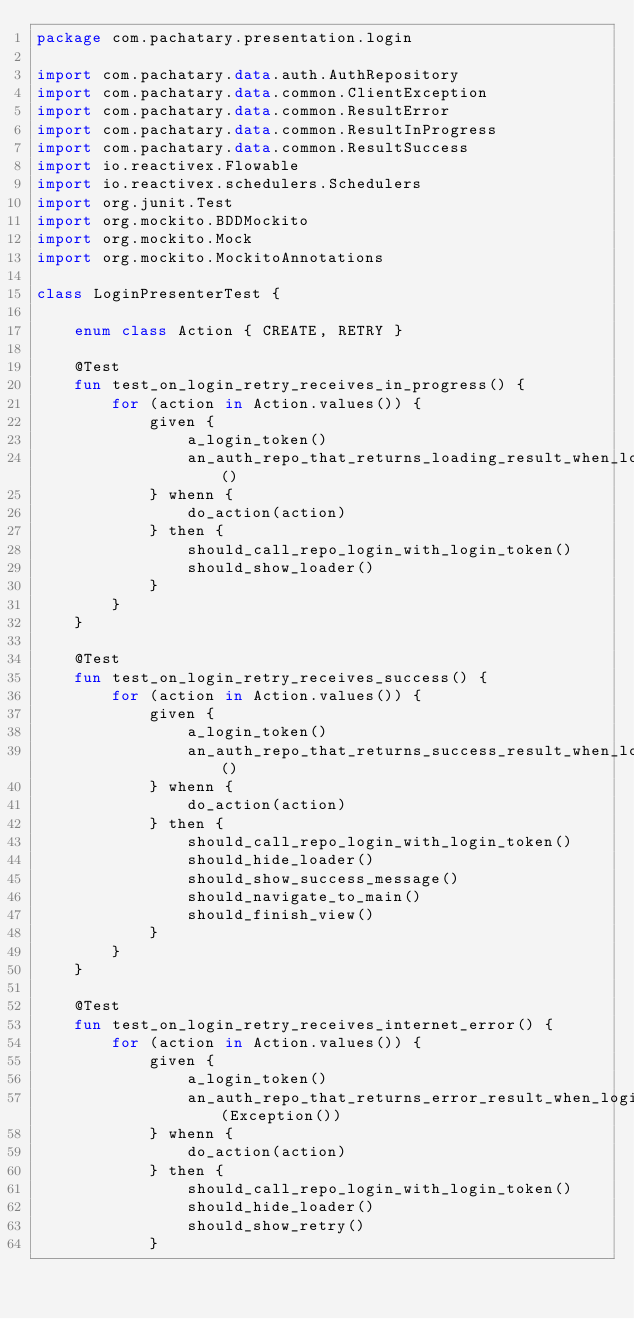<code> <loc_0><loc_0><loc_500><loc_500><_Kotlin_>package com.pachatary.presentation.login

import com.pachatary.data.auth.AuthRepository
import com.pachatary.data.common.ClientException
import com.pachatary.data.common.ResultError
import com.pachatary.data.common.ResultInProgress
import com.pachatary.data.common.ResultSuccess
import io.reactivex.Flowable
import io.reactivex.schedulers.Schedulers
import org.junit.Test
import org.mockito.BDDMockito
import org.mockito.Mock
import org.mockito.MockitoAnnotations

class LoginPresenterTest {

    enum class Action { CREATE, RETRY }

    @Test
    fun test_on_login_retry_receives_in_progress() {
        for (action in Action.values()) {
            given {
                a_login_token()
                an_auth_repo_that_returns_loading_result_when_login()
            } whenn {
                do_action(action)
            } then {
                should_call_repo_login_with_login_token()
                should_show_loader()
            }
        }
    }

    @Test
    fun test_on_login_retry_receives_success() {
        for (action in Action.values()) {
            given {
                a_login_token()
                an_auth_repo_that_returns_success_result_when_login()
            } whenn {
                do_action(action)
            } then {
                should_call_repo_login_with_login_token()
                should_hide_loader()
                should_show_success_message()
                should_navigate_to_main()
                should_finish_view()
            }
        }
    }

    @Test
    fun test_on_login_retry_receives_internet_error() {
        for (action in Action.values()) {
            given {
                a_login_token()
                an_auth_repo_that_returns_error_result_when_login(Exception())
            } whenn {
                do_action(action)
            } then {
                should_call_repo_login_with_login_token()
                should_hide_loader()
                should_show_retry()
            }</code> 